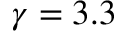Convert formula to latex. <formula><loc_0><loc_0><loc_500><loc_500>\gamma = 3 . 3</formula> 